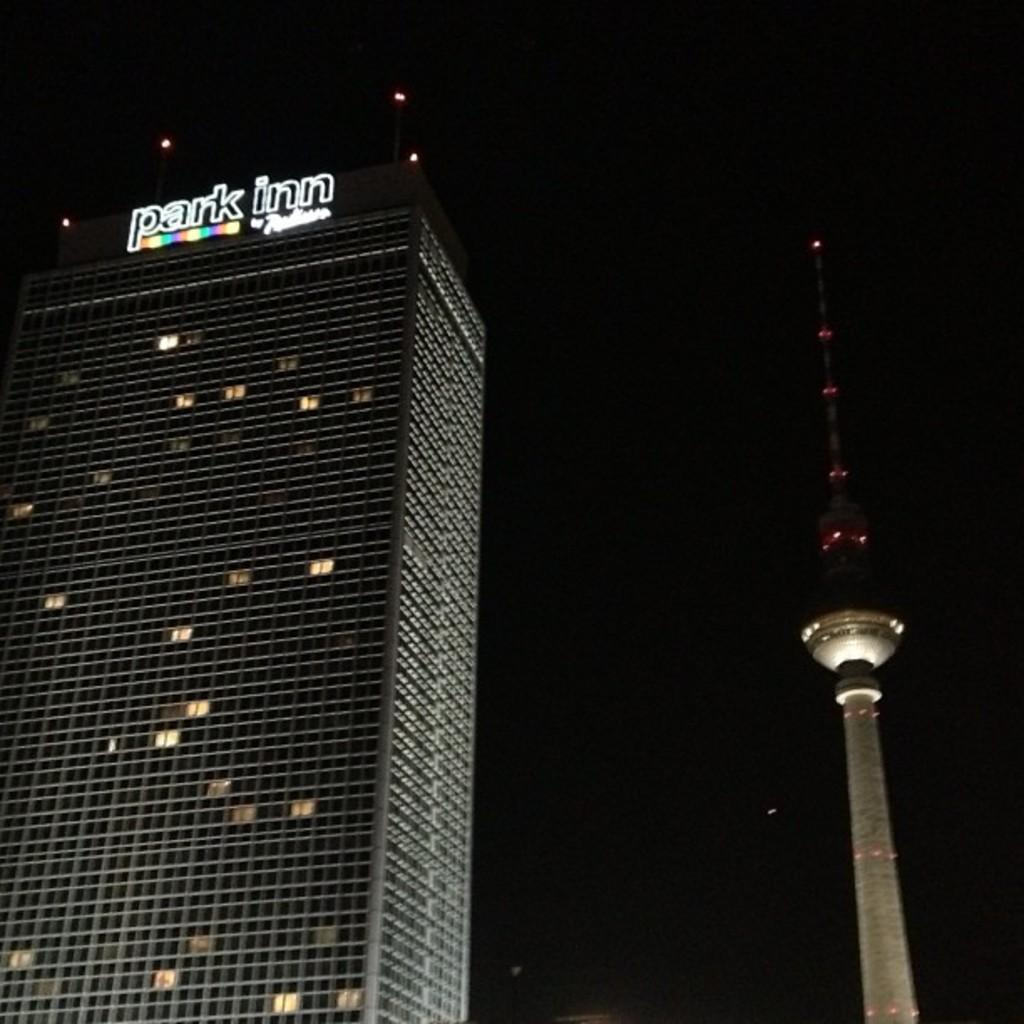What type of structure is visible in the image? There is a building in the image. What other feature can be seen in the image? There is a tower in the image. What is the color of the background in the image? The background of the image is dark. Can you see a bike parked in the bedroom in the image? There is no bike or bedroom present in the image; it features a building and a tower. 